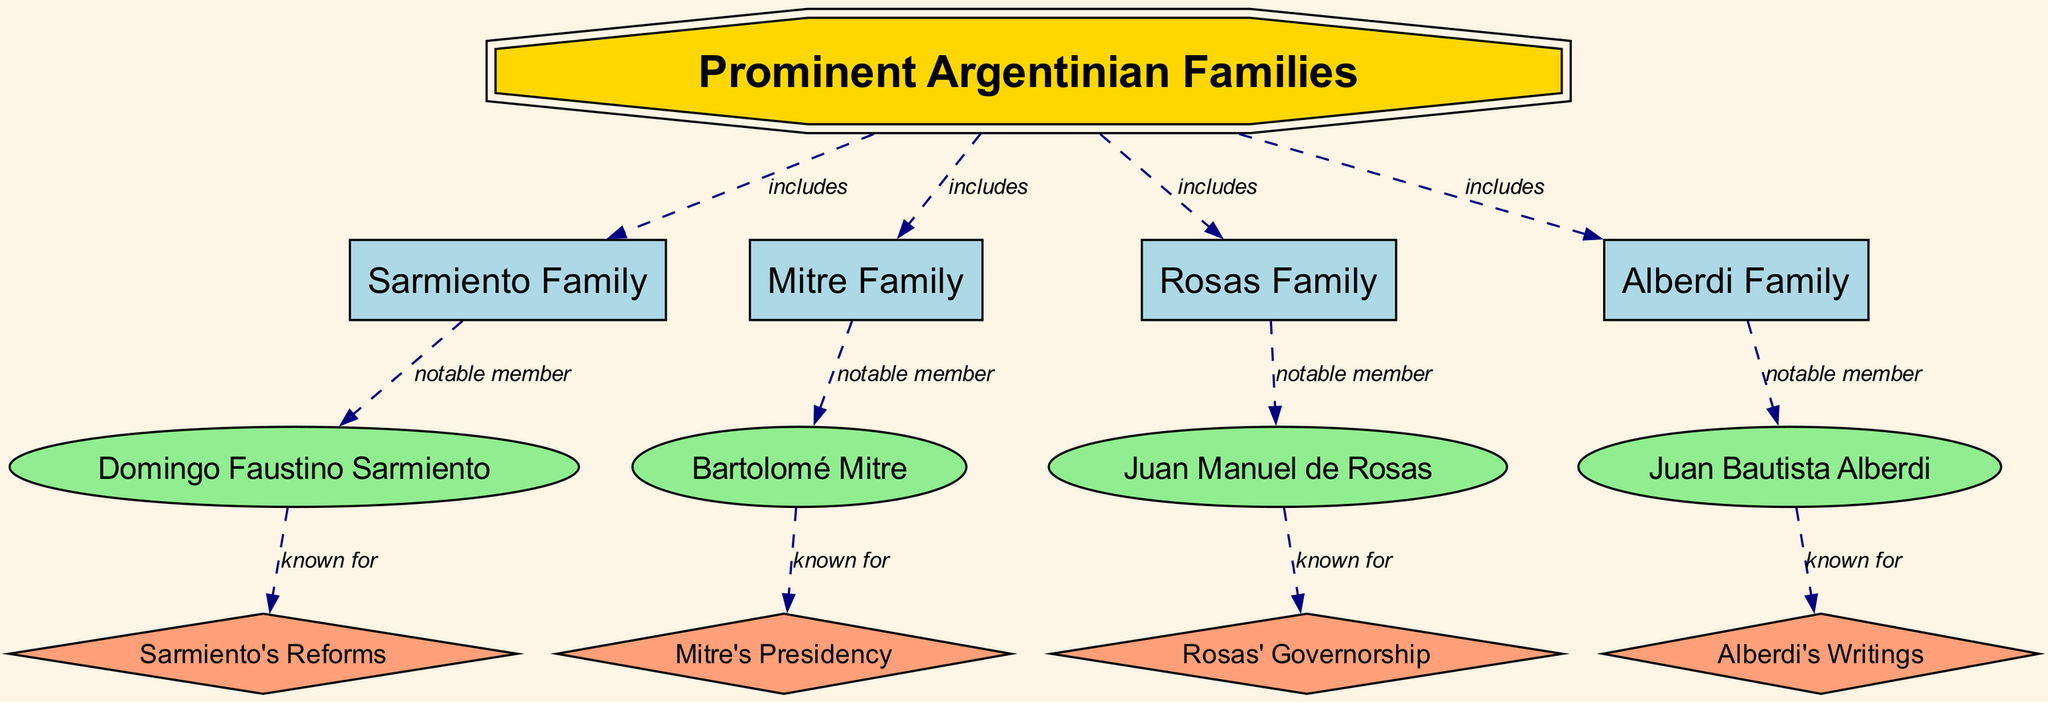What are the names of the prominent Argentinian families included in the diagram? The diagram lists four prominent families: Sarmiento, Mitre, Rosas, and Alberdi. These families are directly connected to the main node labeled "Prominent Argentinian Families," which indicates that they are part of this group.
Answer: Sarmiento, Mitre, Rosas, Alberdi Who is the notable member of the Rosas Family? According to the diagram, the notable member associated with the Rosas Family is Juan Manuel de Rosas. This information is derived from the link between the Rosas Family node and the individual node labeled "Juan Manuel de Rosas."
Answer: Juan Manuel de Rosas How many events are linked to the Sarmiento Family? The Sarmiento Family is connected to one event labeled "Sarmiento's Reforms," which indicates a significant action or contribution attributed to this family. There is only one direct link from Sarmiento Family to this event in the diagram.
Answer: 1 What is the relationship between Bartolomé Mitre and his presidency? The diagram specifically states that Bartolomé Mitre is known for "Mitre's Presidency," which clearly defines a direct relationship between him and the event of his presidency. This link indicates that he is recognized for this contribution.
Answer: known for Which family is associated with "Alberdi's Writings"? The Alberdi Family is linked to the event labeled "Alberdi's Writings." This connection shows that the notable member of the Alberdi Family, Juan Bautista Alberdi, is recognized for this literary contribution. This relationship can be traced from the Alberdi Family node to the event node.
Answer: Alberdi Family 